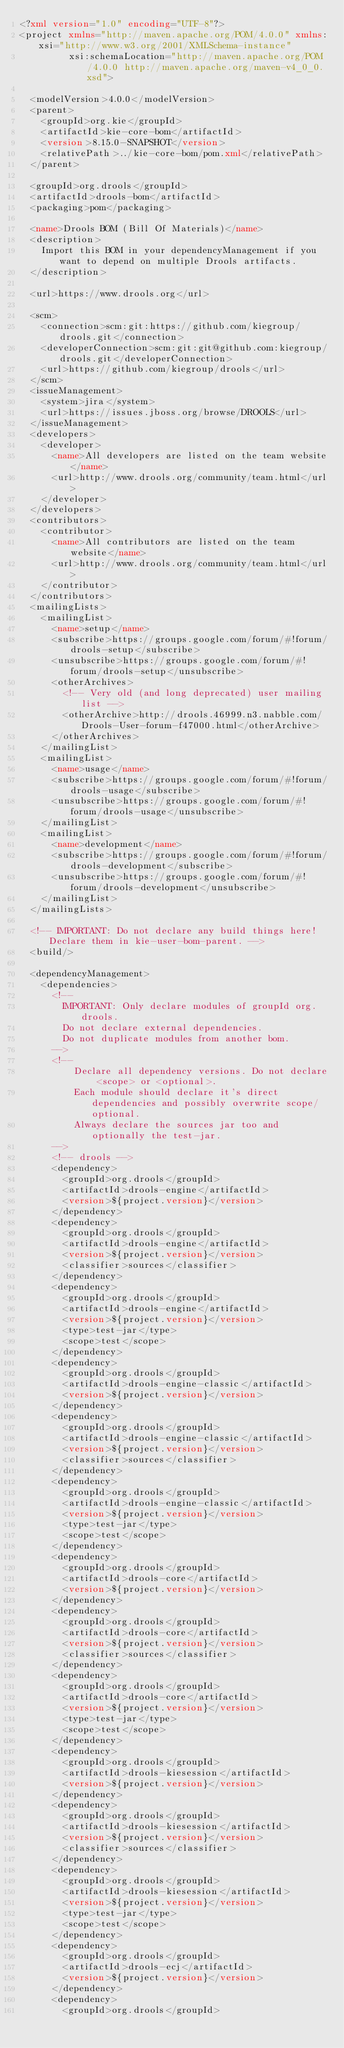<code> <loc_0><loc_0><loc_500><loc_500><_XML_><?xml version="1.0" encoding="UTF-8"?>
<project xmlns="http://maven.apache.org/POM/4.0.0" xmlns:xsi="http://www.w3.org/2001/XMLSchema-instance"
         xsi:schemaLocation="http://maven.apache.org/POM/4.0.0 http://maven.apache.org/maven-v4_0_0.xsd">

  <modelVersion>4.0.0</modelVersion>
  <parent>
    <groupId>org.kie</groupId>
    <artifactId>kie-core-bom</artifactId>
    <version>8.15.0-SNAPSHOT</version>
    <relativePath>../kie-core-bom/pom.xml</relativePath>
  </parent>

  <groupId>org.drools</groupId>
  <artifactId>drools-bom</artifactId>
  <packaging>pom</packaging>

  <name>Drools BOM (Bill Of Materials)</name>
  <description>
    Import this BOM in your dependencyManagement if you want to depend on multiple Drools artifacts.
  </description>

  <url>https://www.drools.org</url>

  <scm>
    <connection>scm:git:https://github.com/kiegroup/drools.git</connection>
    <developerConnection>scm:git:git@github.com:kiegroup/drools.git</developerConnection>
    <url>https://github.com/kiegroup/drools</url>
  </scm>
  <issueManagement>
    <system>jira</system>
    <url>https://issues.jboss.org/browse/DROOLS</url>
  </issueManagement>
  <developers>
    <developer>
      <name>All developers are listed on the team website</name>
      <url>http://www.drools.org/community/team.html</url>
    </developer>
  </developers>
  <contributors>
    <contributor>
      <name>All contributors are listed on the team website</name>
      <url>http://www.drools.org/community/team.html</url>
    </contributor>
  </contributors>
  <mailingLists>
    <mailingList>
      <name>setup</name>
      <subscribe>https://groups.google.com/forum/#!forum/drools-setup</subscribe>
      <unsubscribe>https://groups.google.com/forum/#!forum/drools-setup</unsubscribe>
      <otherArchives>
        <!-- Very old (and long deprecated) user mailing list -->
        <otherArchive>http://drools.46999.n3.nabble.com/Drools-User-forum-f47000.html</otherArchive>
      </otherArchives>
    </mailingList>
    <mailingList>
      <name>usage</name>
      <subscribe>https://groups.google.com/forum/#!forum/drools-usage</subscribe>
      <unsubscribe>https://groups.google.com/forum/#!forum/drools-usage</unsubscribe>
    </mailingList>
    <mailingList>
      <name>development</name>
      <subscribe>https://groups.google.com/forum/#!forum/drools-development</subscribe>
      <unsubscribe>https://groups.google.com/forum/#!forum/drools-development</unsubscribe>
    </mailingList>
  </mailingLists>

  <!-- IMPORTANT: Do not declare any build things here! Declare them in kie-user-bom-parent. -->
  <build/>

  <dependencyManagement>
    <dependencies>
      <!--
        IMPORTANT: Only declare modules of groupId org.drools.
        Do not declare external dependencies.
        Do not duplicate modules from another bom.
      -->
      <!--
          Declare all dependency versions. Do not declare <scope> or <optional>.
          Each module should declare it's direct dependencies and possibly overwrite scope/optional.
          Always declare the sources jar too and optionally the test-jar.
      -->
      <!-- drools -->
      <dependency>
        <groupId>org.drools</groupId>
        <artifactId>drools-engine</artifactId>
        <version>${project.version}</version>
      </dependency>
      <dependency>
        <groupId>org.drools</groupId>
        <artifactId>drools-engine</artifactId>
        <version>${project.version}</version>
        <classifier>sources</classifier>
      </dependency>
      <dependency>
        <groupId>org.drools</groupId>
        <artifactId>drools-engine</artifactId>
        <version>${project.version}</version>
        <type>test-jar</type>
        <scope>test</scope>
      </dependency>
      <dependency>
        <groupId>org.drools</groupId>
        <artifactId>drools-engine-classic</artifactId>
        <version>${project.version}</version>
      </dependency>
      <dependency>
        <groupId>org.drools</groupId>
        <artifactId>drools-engine-classic</artifactId>
        <version>${project.version}</version>
        <classifier>sources</classifier>
      </dependency>
      <dependency>
        <groupId>org.drools</groupId>
        <artifactId>drools-engine-classic</artifactId>
        <version>${project.version}</version>
        <type>test-jar</type>
        <scope>test</scope>
      </dependency>
      <dependency>
        <groupId>org.drools</groupId>
        <artifactId>drools-core</artifactId>
        <version>${project.version}</version>
      </dependency>
      <dependency>
        <groupId>org.drools</groupId>
        <artifactId>drools-core</artifactId>
        <version>${project.version}</version>
        <classifier>sources</classifier>
      </dependency>
      <dependency>
        <groupId>org.drools</groupId>
        <artifactId>drools-core</artifactId>
        <version>${project.version}</version>
        <type>test-jar</type>
        <scope>test</scope>
      </dependency>
      <dependency>
        <groupId>org.drools</groupId>
        <artifactId>drools-kiesession</artifactId>
        <version>${project.version}</version>
      </dependency>
      <dependency>
        <groupId>org.drools</groupId>
        <artifactId>drools-kiesession</artifactId>
        <version>${project.version}</version>
        <classifier>sources</classifier>
      </dependency>
      <dependency>
        <groupId>org.drools</groupId>
        <artifactId>drools-kiesession</artifactId>
        <version>${project.version}</version>
        <type>test-jar</type>
        <scope>test</scope>
      </dependency>
      <dependency>
        <groupId>org.drools</groupId>
        <artifactId>drools-ecj</artifactId>
        <version>${project.version}</version>
      </dependency>
      <dependency>
        <groupId>org.drools</groupId></code> 